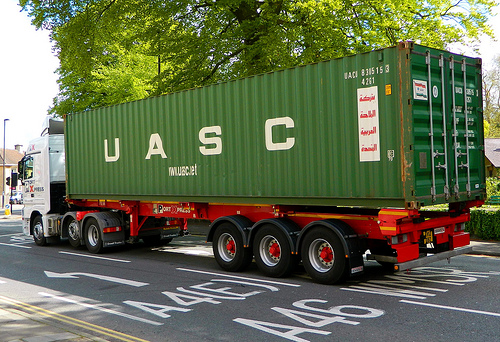Is the container green? Yes, the container is green. 